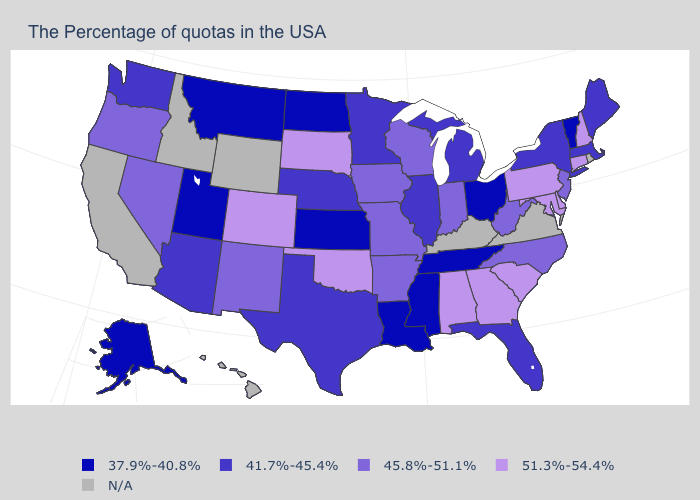Among the states that border Missouri , which have the highest value?
Give a very brief answer. Oklahoma. Name the states that have a value in the range 37.9%-40.8%?
Keep it brief. Vermont, Ohio, Tennessee, Mississippi, Louisiana, Kansas, North Dakota, Utah, Montana, Alaska. Which states hav the highest value in the West?
Be succinct. Colorado. Which states hav the highest value in the South?
Keep it brief. Delaware, Maryland, South Carolina, Georgia, Alabama, Oklahoma. What is the value of Michigan?
Give a very brief answer. 41.7%-45.4%. What is the value of Pennsylvania?
Write a very short answer. 51.3%-54.4%. Among the states that border Oklahoma , which have the highest value?
Write a very short answer. Colorado. Name the states that have a value in the range 51.3%-54.4%?
Answer briefly. New Hampshire, Connecticut, Delaware, Maryland, Pennsylvania, South Carolina, Georgia, Alabama, Oklahoma, South Dakota, Colorado. Among the states that border Colorado , does Kansas have the highest value?
Quick response, please. No. Which states have the highest value in the USA?
Keep it brief. New Hampshire, Connecticut, Delaware, Maryland, Pennsylvania, South Carolina, Georgia, Alabama, Oklahoma, South Dakota, Colorado. Among the states that border West Virginia , which have the highest value?
Short answer required. Maryland, Pennsylvania. What is the value of Maine?
Be succinct. 41.7%-45.4%. What is the lowest value in the MidWest?
Give a very brief answer. 37.9%-40.8%. 